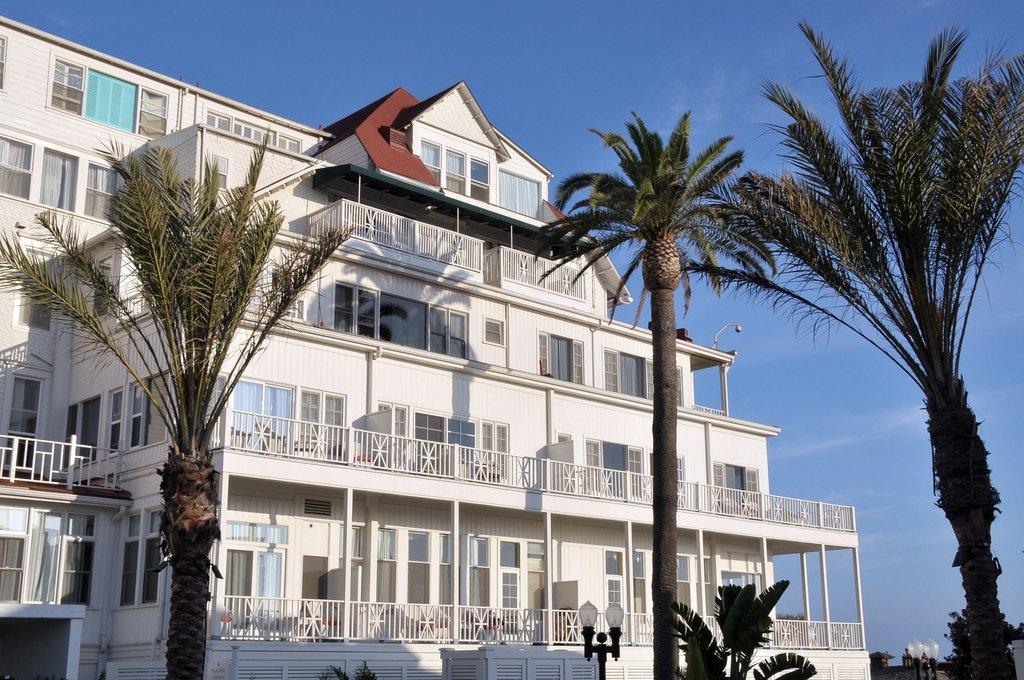What type of structure is present in the image? There is a building in the image. What can be seen illuminated in the image? There are lights visible in the image. What type of vegetation is present in the image? There are trees in the image. What is visible in the background of the image? The sky is visible in the background of the image. Can you hear the yak sneezing in the image? There is no yak or sneezing present in the image. Is the image taken during a rainy day? The image does not provide any information about the weather, so it cannot be determined if it was taken during a rainy day. 